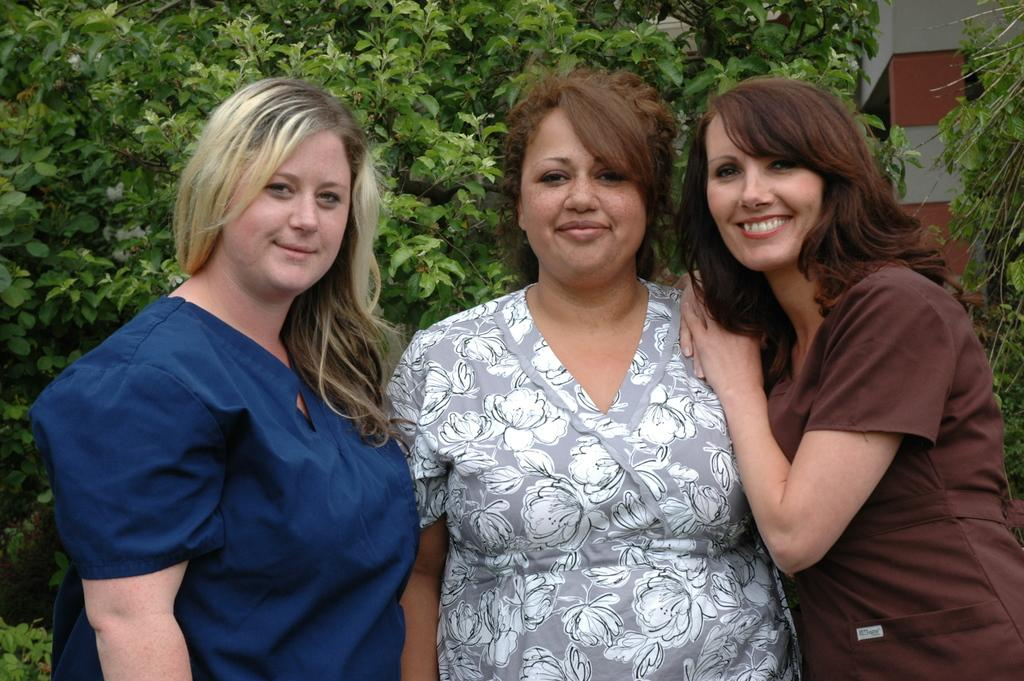How many women are present in the image? There are three women in the image. What expression do the women have? The women are smiling. What can be seen in the background of the image? There are trees and a pillar in the background of the image. What type of line can be seen moving across the image? There is no line moving across the image; it only features three women and background elements. What sound can be heard coming from the women in the image? There is no sound present in the image, as it is a still photograph. 